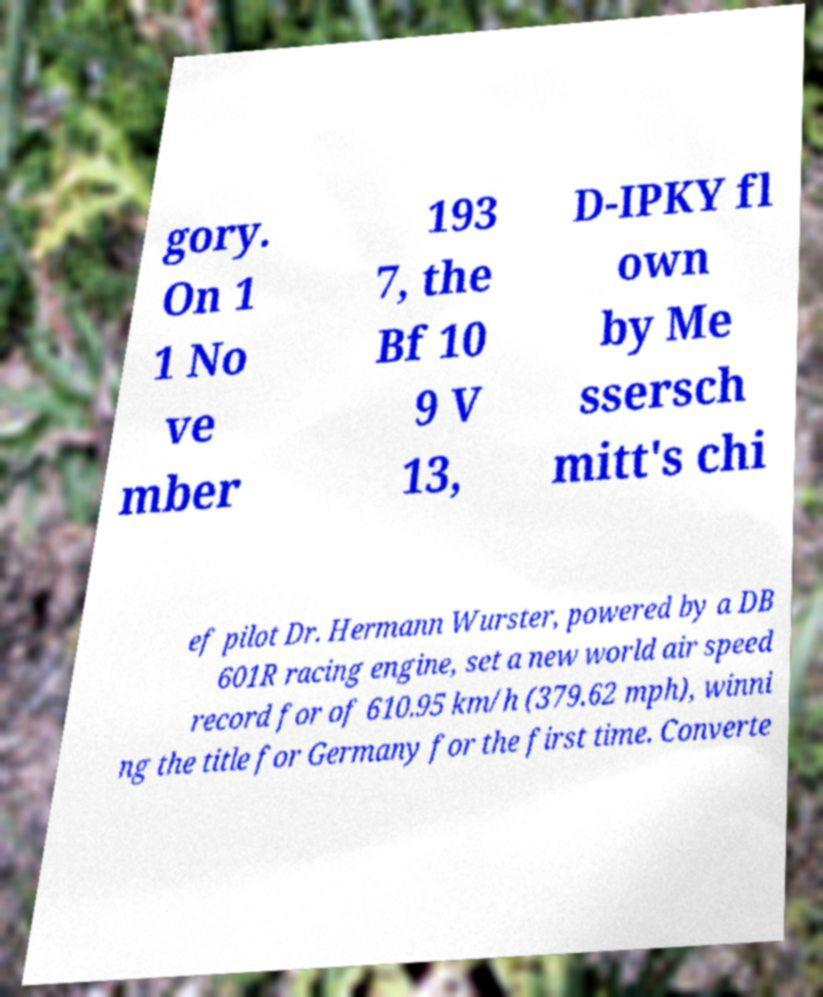Can you read and provide the text displayed in the image?This photo seems to have some interesting text. Can you extract and type it out for me? gory. On 1 1 No ve mber 193 7, the Bf 10 9 V 13, D-IPKY fl own by Me ssersch mitt's chi ef pilot Dr. Hermann Wurster, powered by a DB 601R racing engine, set a new world air speed record for of 610.95 km/h (379.62 mph), winni ng the title for Germany for the first time. Converte 